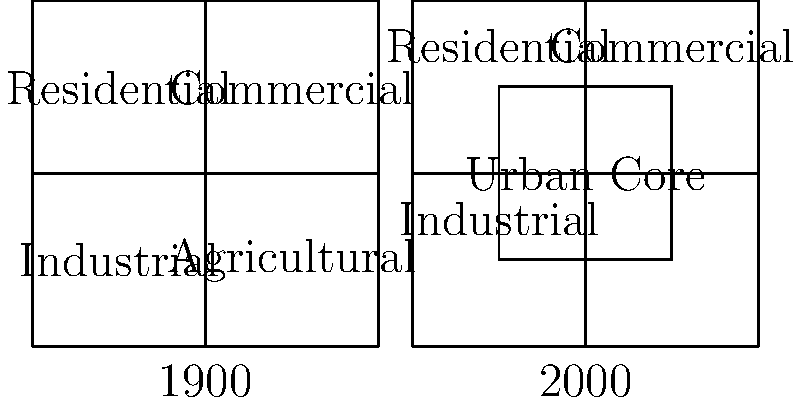Analyze the historical maps of Watertown from 1900 and 2000. What is the most significant change in land use patterns between these two time periods? To answer this question, let's analyze the changes in land use patterns step by step:

1. 1900 Map:
   - The map is divided into four equal quadrants.
   - Top-left: Residential
   - Top-right: Commercial
   - Bottom-left: Industrial
   - Bottom-right: Agricultural

2. 2000 Map:
   - The map still has four main sections, but with a new central area.
   - Top-left: Residential (smaller than 1900)
   - Top-right: Commercial (smaller than 1900)
   - Bottom-left: Industrial (smaller than 1900)
   - Center: New Urban Core (not present in 1900)

3. Key Changes:
   - Introduction of an Urban Core in the center of the map.
   - Reduction in size of Residential, Commercial, and Industrial areas.
   - Complete disappearance of the Agricultural area.

4. Most Significant Change:
   The most significant change is the disappearance of the Agricultural area and its replacement with an Urban Core. This indicates a major shift from rural to urban land use, reflecting the growth and development of Watertown over the century.
Answer: Disappearance of Agricultural land and emergence of an Urban Core 